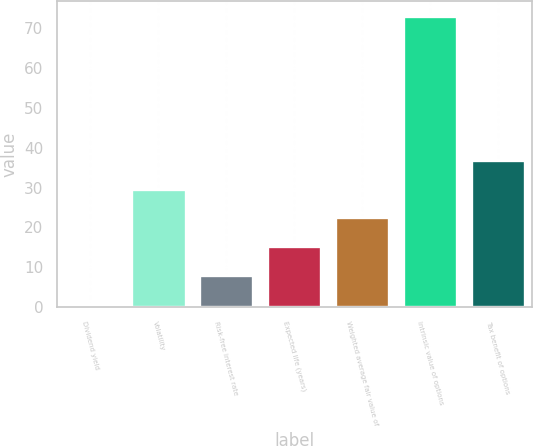Convert chart to OTSL. <chart><loc_0><loc_0><loc_500><loc_500><bar_chart><fcel>Dividend yield<fcel>Volatility<fcel>Risk-free interest rate<fcel>Expected life (years)<fcel>Weighted average fair value of<fcel>Intrinsic value of options<fcel>Tax benefit of options<nl><fcel>0.9<fcel>29.74<fcel>8.11<fcel>15.32<fcel>22.53<fcel>73<fcel>36.95<nl></chart> 